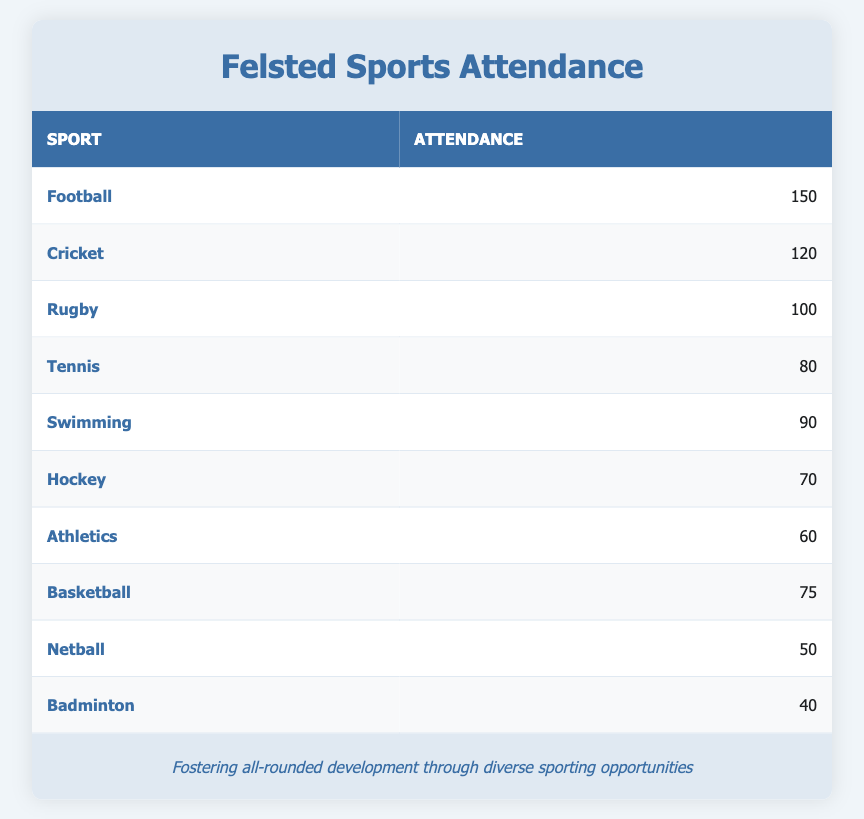What sport had the highest attendance? The table lists sports alongside their attendance numbers. The sport with the highest attendance is Football, which has 150 participants.
Answer: Football How many students attended Rugby? The table indicates the attendance for Rugby is listed as 100. Therefore, 100 students attended Rugby.
Answer: 100 Which two sports had the lowest attendance? By examining the attendance figures, we see Badminton with 40 and Netball with 50 participants. These two sports have the lowest attendance numbers.
Answer: Badminton and Netball What is the total attendance for Tennis and Swimming? The attendance for Tennis is 80 and for Swimming is 90. Adding these two gives a total attendance of 80 + 90 = 170.
Answer: 170 Is the attendance for Athletics greater than that for Hockey? According to the table, Athletics has an attendance of 60, while Hockey has 70. Since 60 is not greater than 70, the answer is no.
Answer: No What is the average attendance across all listed sports? First, we sum all the attendances: 150 + 120 + 100 + 80 + 90 + 70 + 60 + 75 + 50 + 40 = 995. There are 10 sports, so the average is 995 / 10 = 99.5.
Answer: 99.5 Which sport has an attendance that is 10 more than Basketball? The attendance for Basketball is 75, so adding 10 gives 85. Looking at the table, Tennis has a corresponding attendance of 80, which is the closest but does not meet the criteria. No sport matches exactly with 85 attendance.
Answer: None How many more students attended Cricket than Hockey? Cricket attendance is 120 and Hockey attendance is 70. Subtracting gives 120 - 70 = 50, indicating that 50 more students attended Cricket compared to Hockey.
Answer: 50 Which sports had an attendance of 90 or more students? The table shows that Football (150), Cricket (120), Rugby (100), Swimming (90) all have attendance of 90 or more. Therefore, these four sports meet the criterion.
Answer: Football, Cricket, Rugby, Swimming 